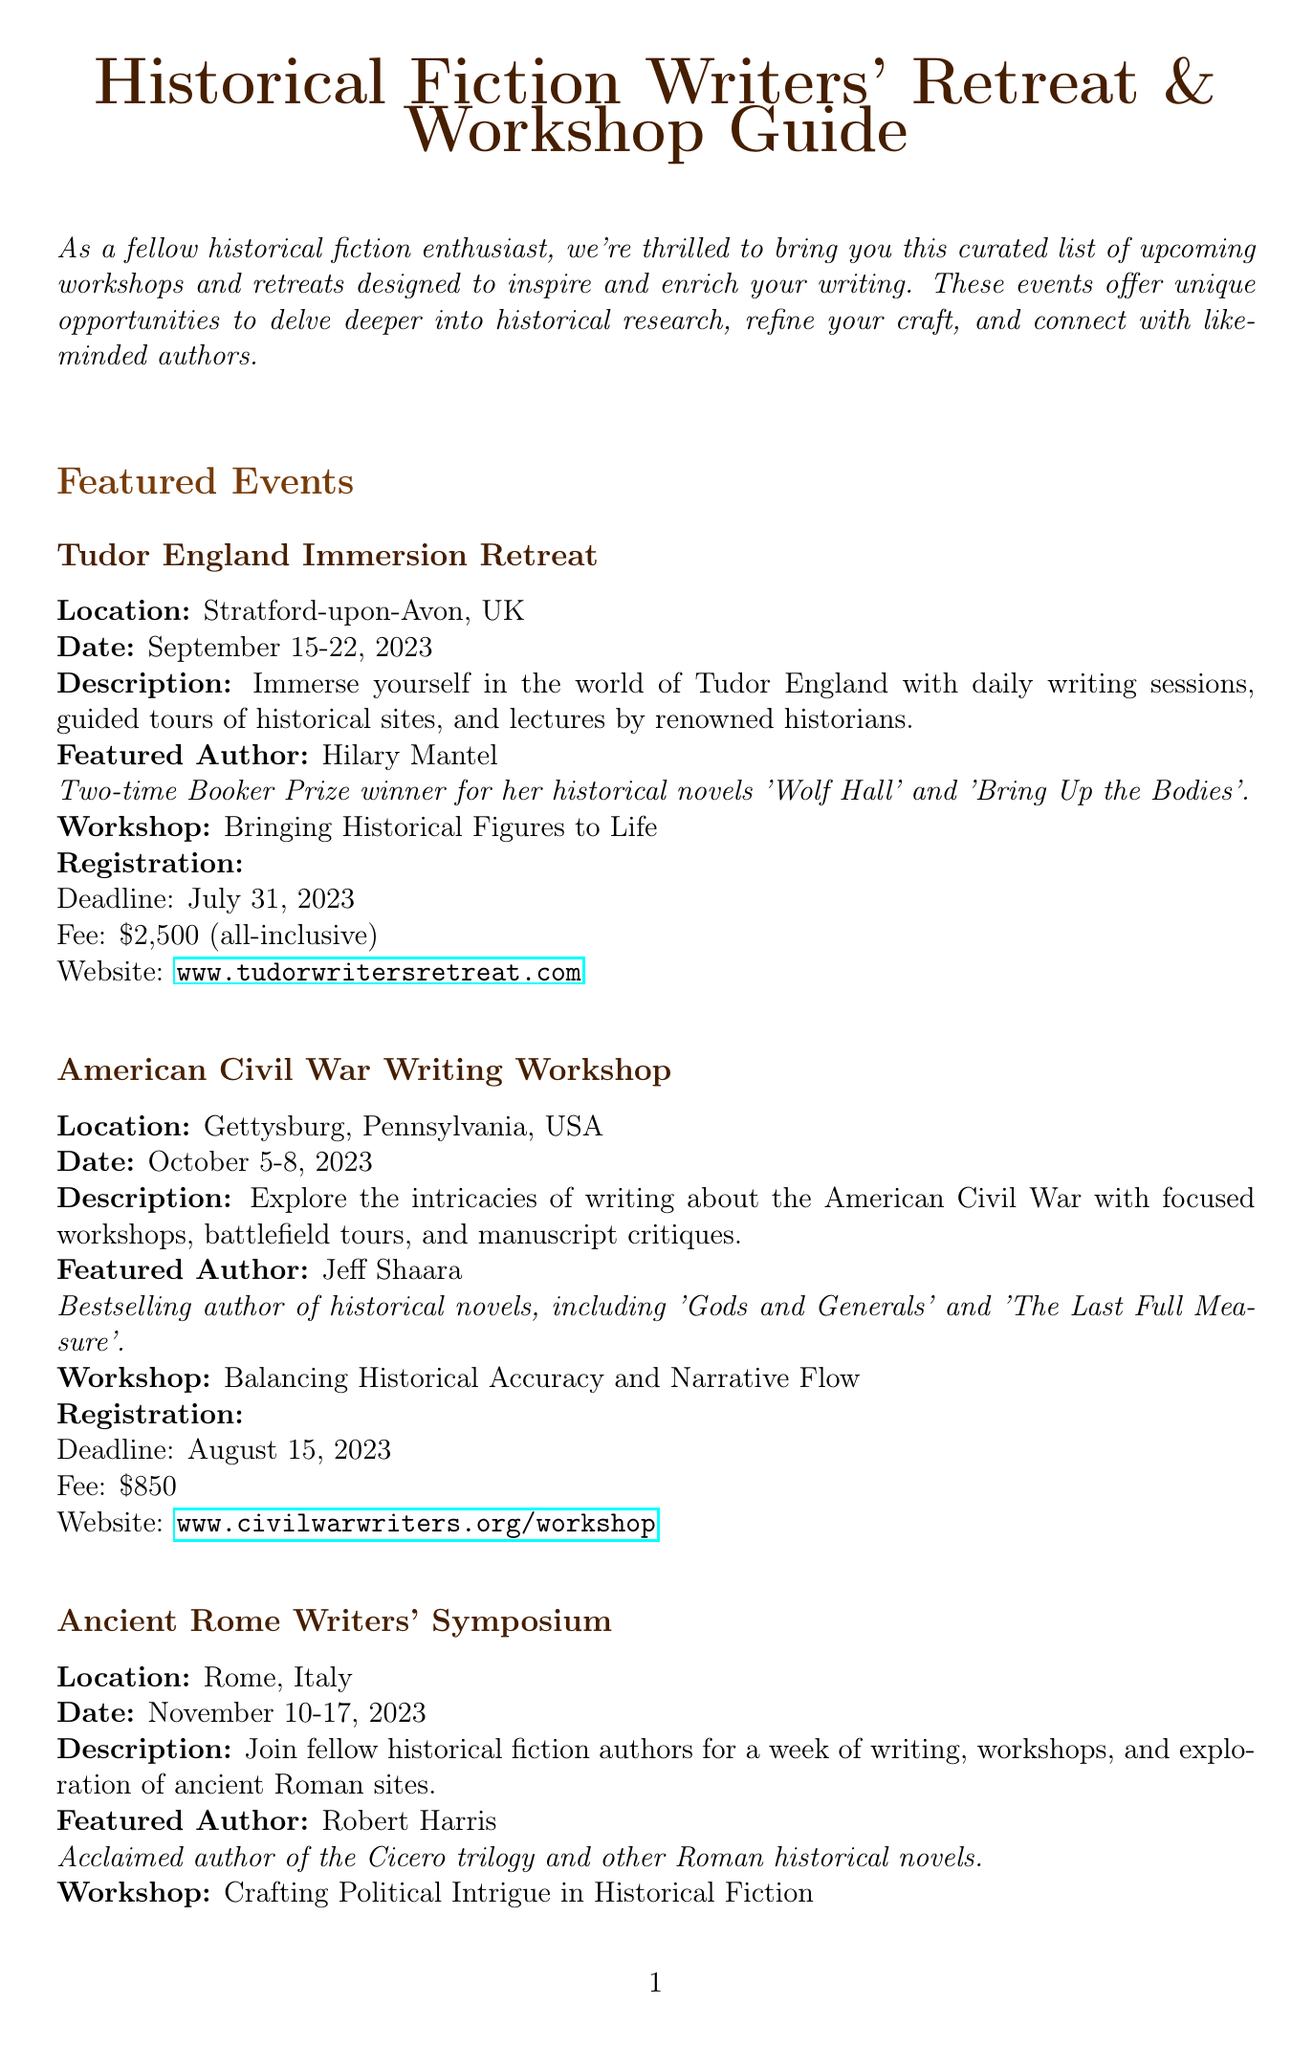What is the location of the Tudor England Immersion Retreat? The location is specified under the Tudor England Immersion Retreat section.
Answer: Stratford-upon-Avon, UK Who is the featured author for the Ancient Rome Writers' Symposium? The featured author is mentioned in the symposium section.
Answer: Robert Harris What is the date for the American Civil War Writing Workshop? The date is explicitly listed in the workshop's event details.
Answer: October 5-8, 2023 What is the registration deadline for the Tudor England Immersion Retreat? The registration deadline is stated in the registration details of the retreat.
Answer: July 31, 2023 What is the fee for the Ancient Rome Writers' Symposium? The fee for the symposium is provided in the registration section.
Answer: €2,200 (accommodation not included) What type of events does this newsletter curate? The introduction describes the purpose of the document and the type of events included.
Answer: Workshops and retreats What kind of workshop is offered by Jeff Shaara? The type of workshop is specified under the details of the American Civil War Writing Workshop.
Answer: Balancing Historical Accuracy and Narrative Flow How many featured events are listed in the document? The number of featured events can be counted from the featured events section.
Answer: Three What is the website for additional resources regarding the Historical Novel Society Conference? The website is provided in the additional resources section.
Answer: www.historicalnovelsociety.org/conference 